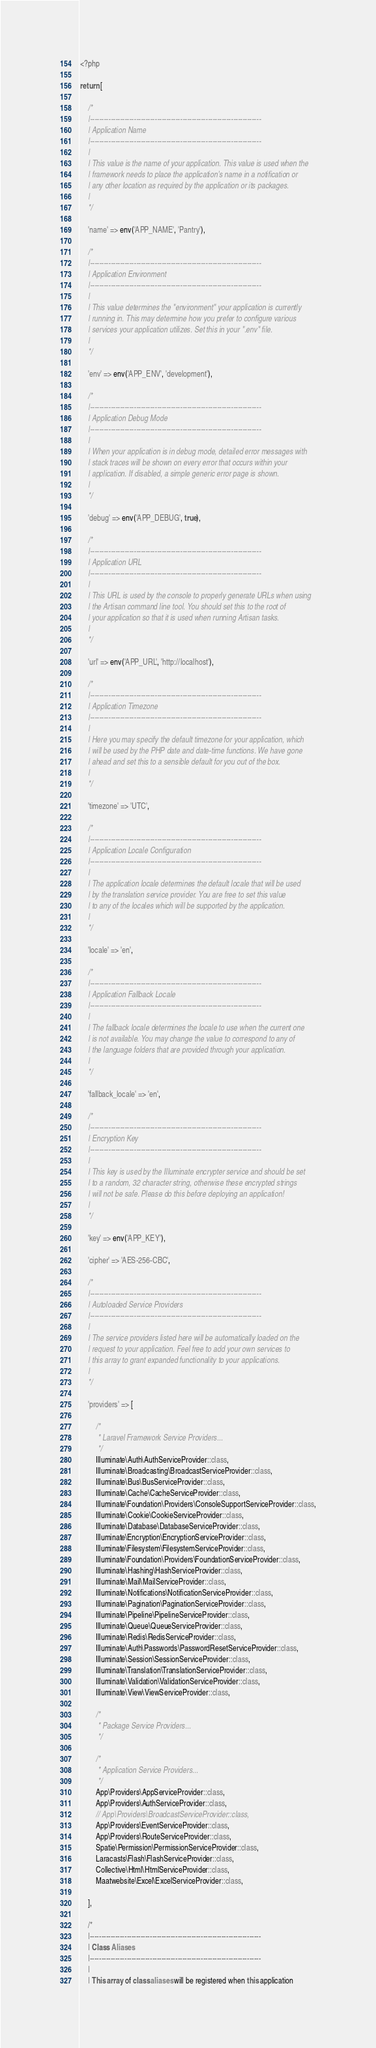<code> <loc_0><loc_0><loc_500><loc_500><_PHP_><?php

return [

    /*
    |--------------------------------------------------------------------------
    | Application Name
    |--------------------------------------------------------------------------
    |
    | This value is the name of your application. This value is used when the
    | framework needs to place the application's name in a notification or
    | any other location as required by the application or its packages.
    |
    */

    'name' => env('APP_NAME', 'Pantry'),

    /*
    |--------------------------------------------------------------------------
    | Application Environment
    |--------------------------------------------------------------------------
    |
    | This value determines the "environment" your application is currently
    | running in. This may determine how you prefer to configure various
    | services your application utilizes. Set this in your ".env" file.
    |
    */

    'env' => env('APP_ENV', 'development'),

    /*
    |--------------------------------------------------------------------------
    | Application Debug Mode
    |--------------------------------------------------------------------------
    |
    | When your application is in debug mode, detailed error messages with
    | stack traces will be shown on every error that occurs within your
    | application. If disabled, a simple generic error page is shown.
    |
    */

    'debug' => env('APP_DEBUG', true),

    /*
    |--------------------------------------------------------------------------
    | Application URL
    |--------------------------------------------------------------------------
    |
    | This URL is used by the console to properly generate URLs when using
    | the Artisan command line tool. You should set this to the root of
    | your application so that it is used when running Artisan tasks.
    |
    */

    'url' => env('APP_URL', 'http://localhost'),

    /*
    |--------------------------------------------------------------------------
    | Application Timezone
    |--------------------------------------------------------------------------
    |
    | Here you may specify the default timezone for your application, which
    | will be used by the PHP date and date-time functions. We have gone
    | ahead and set this to a sensible default for you out of the box.
    |
    */

    'timezone' => 'UTC',

    /*
    |--------------------------------------------------------------------------
    | Application Locale Configuration
    |--------------------------------------------------------------------------
    |
    | The application locale determines the default locale that will be used
    | by the translation service provider. You are free to set this value
    | to any of the locales which will be supported by the application.
    |
    */

    'locale' => 'en',

    /*
    |--------------------------------------------------------------------------
    | Application Fallback Locale
    |--------------------------------------------------------------------------
    |
    | The fallback locale determines the locale to use when the current one
    | is not available. You may change the value to correspond to any of
    | the language folders that are provided through your application.
    |
    */

    'fallback_locale' => 'en',

    /*
    |--------------------------------------------------------------------------
    | Encryption Key
    |--------------------------------------------------------------------------
    |
    | This key is used by the Illuminate encrypter service and should be set
    | to a random, 32 character string, otherwise these encrypted strings
    | will not be safe. Please do this before deploying an application!
    |
    */

    'key' => env('APP_KEY'),

    'cipher' => 'AES-256-CBC',

    /*
    |--------------------------------------------------------------------------
    | Autoloaded Service Providers
    |--------------------------------------------------------------------------
    |
    | The service providers listed here will be automatically loaded on the
    | request to your application. Feel free to add your own services to
    | this array to grant expanded functionality to your applications.
    |
    */

    'providers' => [

        /*
         * Laravel Framework Service Providers...
         */
        Illuminate\Auth\AuthServiceProvider::class,
        Illuminate\Broadcasting\BroadcastServiceProvider::class,
        Illuminate\Bus\BusServiceProvider::class,
        Illuminate\Cache\CacheServiceProvider::class,
        Illuminate\Foundation\Providers\ConsoleSupportServiceProvider::class,
        Illuminate\Cookie\CookieServiceProvider::class,
        Illuminate\Database\DatabaseServiceProvider::class,
        Illuminate\Encryption\EncryptionServiceProvider::class,
        Illuminate\Filesystem\FilesystemServiceProvider::class,
        Illuminate\Foundation\Providers\FoundationServiceProvider::class,
        Illuminate\Hashing\HashServiceProvider::class,
        Illuminate\Mail\MailServiceProvider::class,
        Illuminate\Notifications\NotificationServiceProvider::class,
        Illuminate\Pagination\PaginationServiceProvider::class,
        Illuminate\Pipeline\PipelineServiceProvider::class,
        Illuminate\Queue\QueueServiceProvider::class,
        Illuminate\Redis\RedisServiceProvider::class,
        Illuminate\Auth\Passwords\PasswordResetServiceProvider::class,
        Illuminate\Session\SessionServiceProvider::class,
        Illuminate\Translation\TranslationServiceProvider::class,
        Illuminate\Validation\ValidationServiceProvider::class,
        Illuminate\View\ViewServiceProvider::class,

        /*
         * Package Service Providers...
         */

        /*
         * Application Service Providers...
         */
        App\Providers\AppServiceProvider::class,
        App\Providers\AuthServiceProvider::class,
        // App\Providers\BroadcastServiceProvider::class,
        App\Providers\EventServiceProvider::class,
        App\Providers\RouteServiceProvider::class,
        Spatie\Permission\PermissionServiceProvider::class,
        Laracasts\Flash\FlashServiceProvider::class,        
        Collective\Html\HtmlServiceProvider::class,
        Maatwebsite\Excel\ExcelServiceProvider::class,

    ],

    /*
    |--------------------------------------------------------------------------
    | Class Aliases
    |--------------------------------------------------------------------------
    |
    | This array of class aliases will be registered when this application</code> 